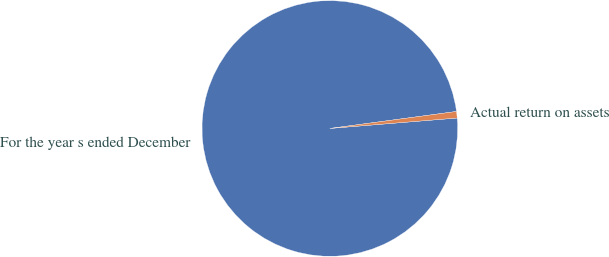<chart> <loc_0><loc_0><loc_500><loc_500><pie_chart><fcel>For the year s ended December<fcel>Actual return on assets<nl><fcel>99.18%<fcel>0.82%<nl></chart> 